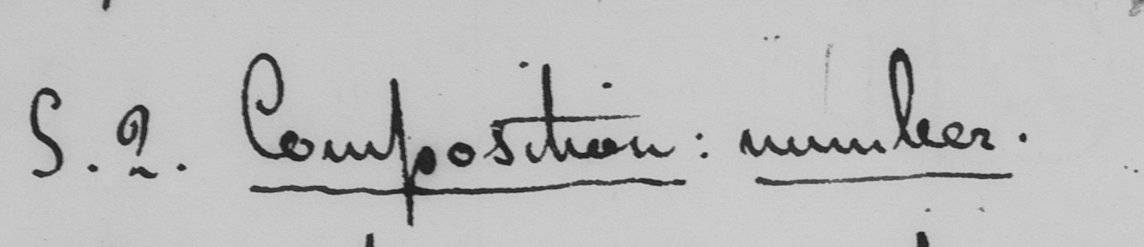Please provide the text content of this handwritten line. S . 2 . Composition :  number 